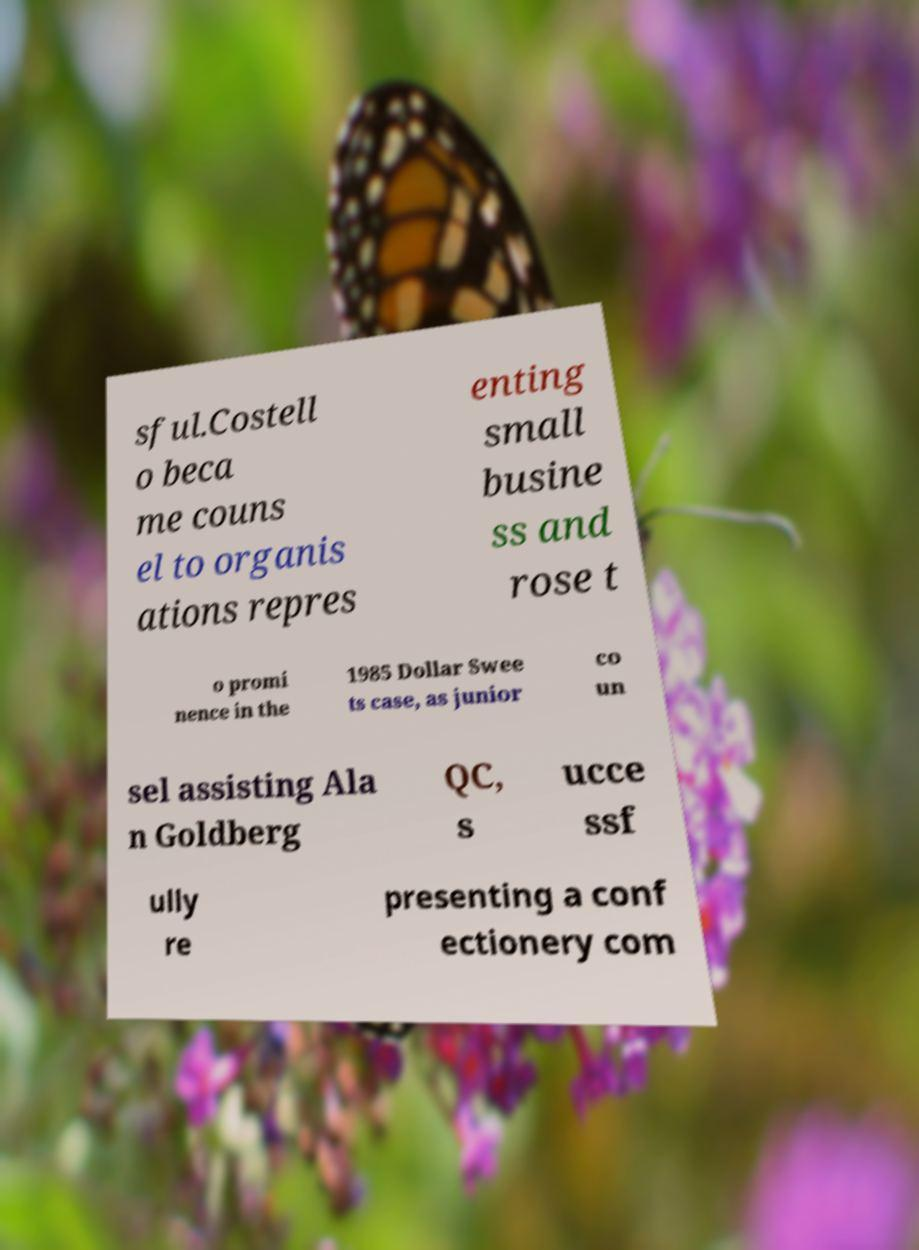Could you extract and type out the text from this image? sful.Costell o beca me couns el to organis ations repres enting small busine ss and rose t o promi nence in the 1985 Dollar Swee ts case, as junior co un sel assisting Ala n Goldberg QC, s ucce ssf ully re presenting a conf ectionery com 